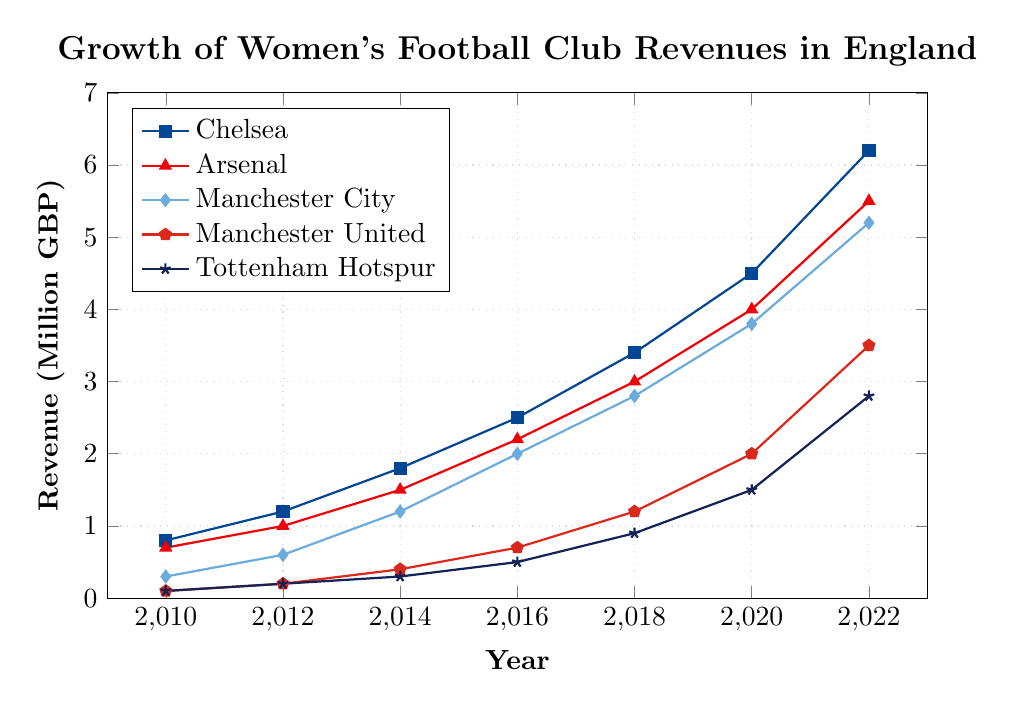What year did Chelsea's revenue surpass 4 million GBP? Locate the Chelsea trend line, marked by squares, and identify the year where the revenue first exceeds 4 million GBP. By examining the chart, it occurs between 2018 and 2020.
Answer: 2020 Which club had the highest revenue in 2012, and what was the value? Compare all club revenues in 2012 shown on the y-axis. Chelsea's data point is highest at around 1.2 million GBP.
Answer: Chelsea, 1.2 million GBP Between 2010 and 2022, which club showed the greatest increase in revenue? Calculate the revenue increase for each club by subtracting their 2010 value from their 2022 value. Chelsea increased from 0.8 to 6.2 million (an increase of 5.4 million), Arsenal from 0.7 to 5.5 million (4.8 million), Manchester City from 0.3 to 5.2 million (4.9 million), Manchester United from 0.1 to 3.5 million (3.4 million), Tottenham from 0.1 to 2.8 million (2.7 million).
Answer: Chelsea By how much did Tottenham's revenue increase from 2014 to 2022? Find Tottenham’s revenue in 2014 (0.3 million GBP) and in 2022 (2.8 million GBP), then perform the subtraction: 2.8 million - 0.3 million.
Answer: 2.5 million GBP In which year did Arsenal's revenue surpass 3 million GBP, and what was the exact revenue that year? Locate the Arsenal trend line, marked by triangles, finding the period over 3 million GBP. This occurs in 2018 with a revenue around 3.0 million GBP.
Answer: 2018, 3.0 million GBP Compare the revenue of Manchester United and Manchester City in 2014. Which club had a higher revenue and by how much? Locate the points for both clubs in 2014. Manchester United had 0.4 million GBP, and Manchester City had 1.2 million GBP. Subtract Manchester United’s revenue from Manchester City’s.
Answer: Manchester City by 0.8 million GBP What is the average revenue of Tottenham in the years 2010, 2012, and 2014? Sum the revenues of Tottenham in 2010 (0.1 million GBP), 2012 (0.2 million GBP), and 2014 (0.3 million GBP), then divide by 3. (0.1 + 0.2 + 0.3) / 3.
Answer: 0.2 million GBP Which two clubs had the closest revenue values in 2018, and what were their respective revenues? Compare the revenue values in 2018. Tottenham and Manchester United are closest with Tottenham at 0.9 million GBP and Manchester United at 1.2 million GBP.
Answer: Tottenham (0.9 million GBP) and Manchester United (1.2 million GBP) If the revenue increments from 2020 to 2022 for Arsenal and Chelsea remain constant, what would be Chelsea’s projected revenue in 2024? Calculate the increment for Chelsea from 2020 to 2022 (6.2 million - 4.5 million = 1.7 million). If the increment remains constant, add it to the 2022 value: 6.2 million + 1.7 million.
Answer: 7.9 million GBP Which club had the lowest revenue growth rate from 2010 to 2022, and what was the growth? Calculate the rate of revenue change for all clubs from 2010 to 2022 by subtracting the 2010 value from the 2022 value. Tottenham grew from 0.1 million to 2.8 million (2.7 million growth), the smallest increase.
Answer: Tottenham, 2.7 million GBP 